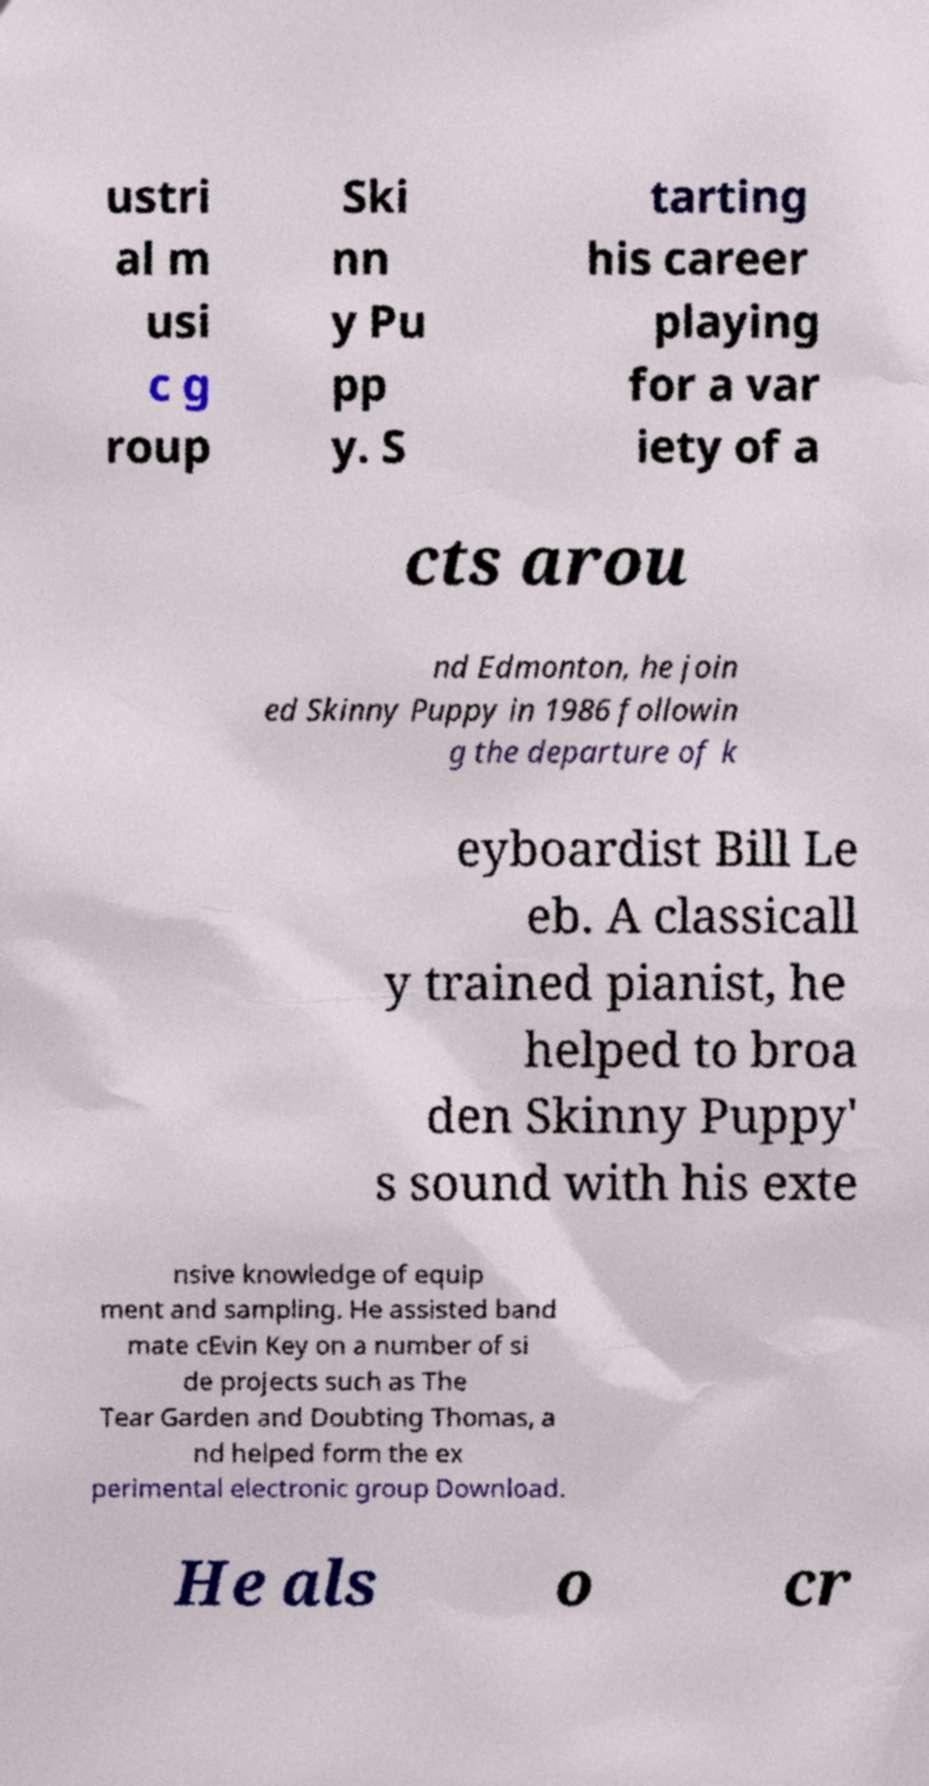What messages or text are displayed in this image? I need them in a readable, typed format. ustri al m usi c g roup Ski nn y Pu pp y. S tarting his career playing for a var iety of a cts arou nd Edmonton, he join ed Skinny Puppy in 1986 followin g the departure of k eyboardist Bill Le eb. A classicall y trained pianist, he helped to broa den Skinny Puppy' s sound with his exte nsive knowledge of equip ment and sampling. He assisted band mate cEvin Key on a number of si de projects such as The Tear Garden and Doubting Thomas, a nd helped form the ex perimental electronic group Download. He als o cr 